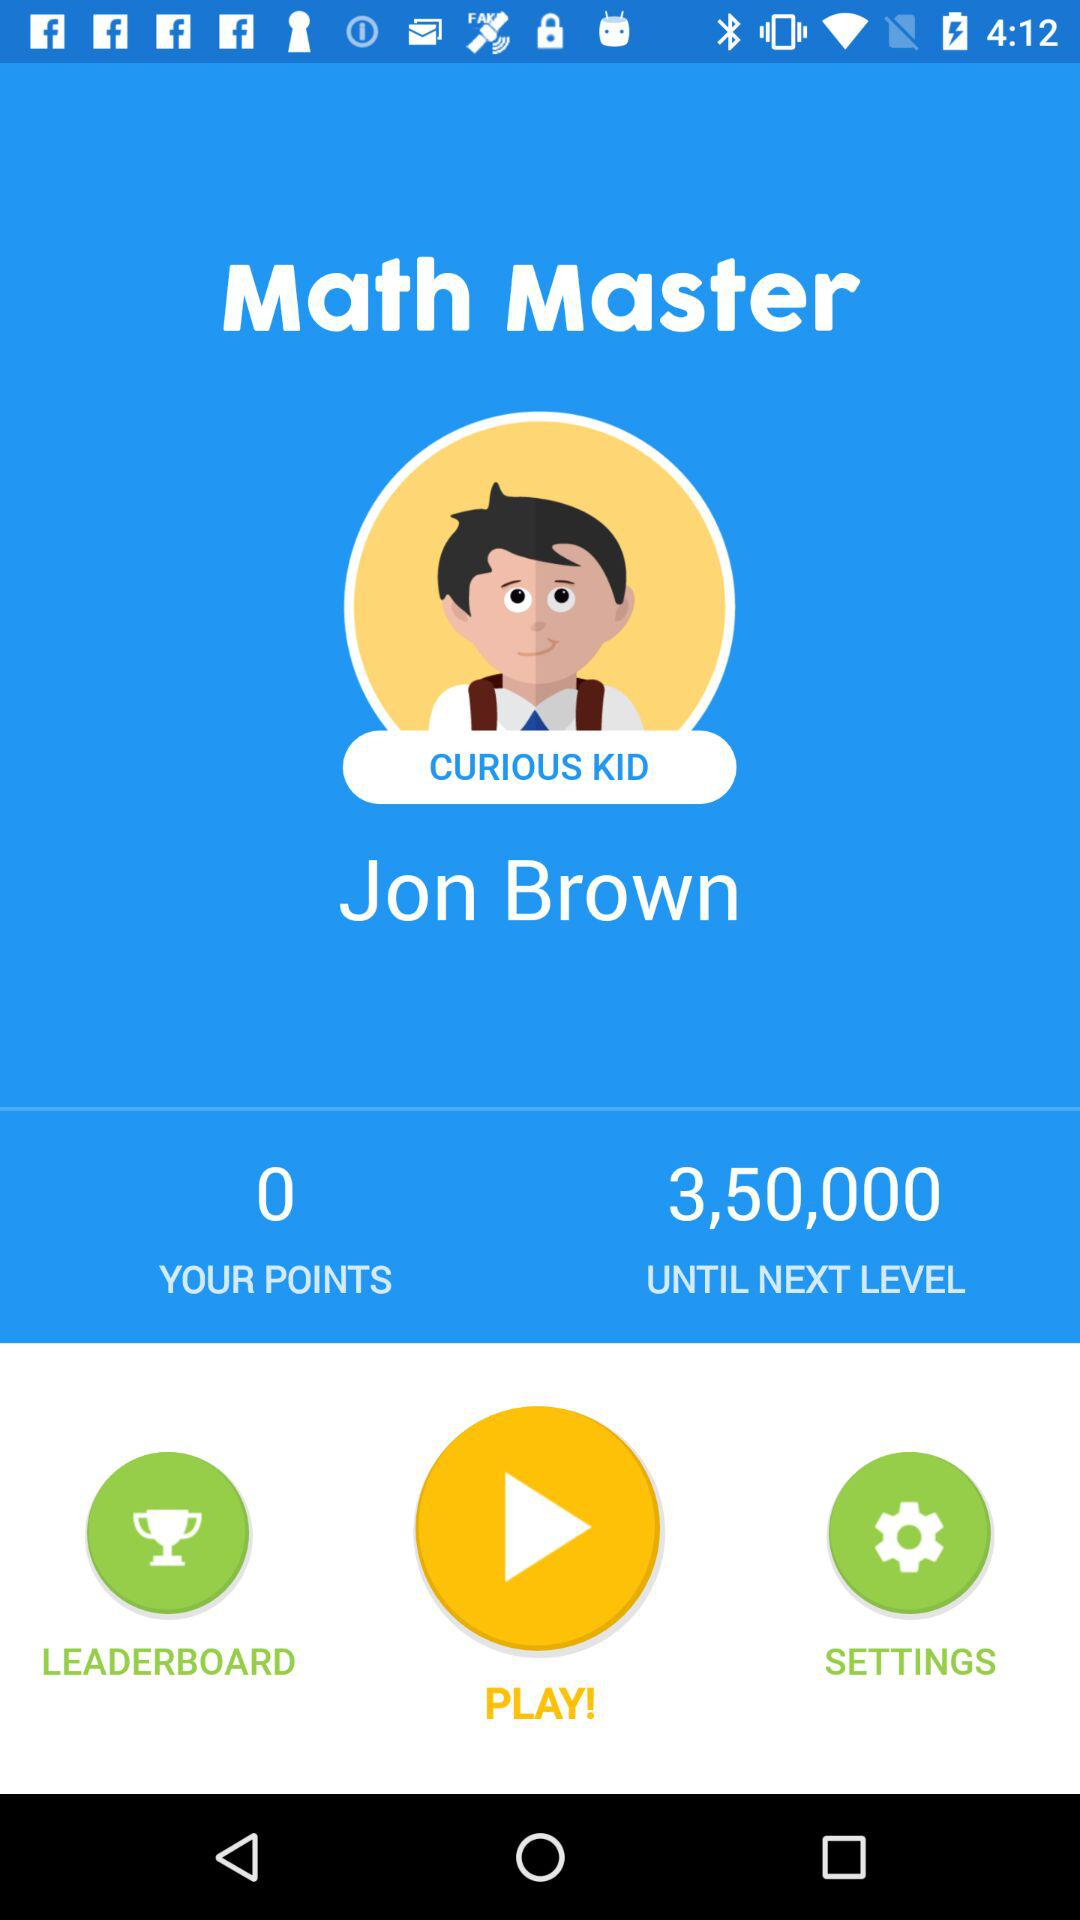How many points do I need to earn to reach the next level?
Answer the question using a single word or phrase. 3,50,000 